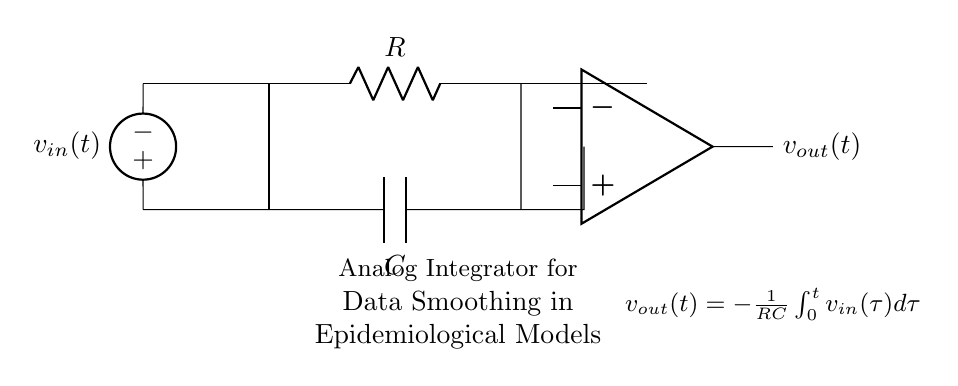What is the primary function of the circuit? The primary function of this circuit is to act as an analog integrator, which smooths data in real-time. This is indicated by the output equation and the arrangement of components.
Answer: Analog integrator What type of components are present in the circuit? The circuit comprises a resistor and a capacitor, which are essential elements for implementing integration in analog circuits. Each component's symbol identifies its role in the circuit.
Answer: Resistor and capacitor What is the output voltage equation for this circuit? The output voltage is given by the equation v out of t equals negative one over RC times the integral of v in from zero to t. This is noted in the circuit diagram.
Answer: v out(t) = -1/RC ∫ v in(τ) dτ How does the resistor value affect the circuit's behavior? The resistor value influences the time constant (RC), which determines how quickly the circuit integrates the input signal. A higher resistance results in a slower response, while a lower resistance leads to faster integration.
Answer: Changes time constant What happens to the output when the input voltage increases? When the input voltage increases, the output voltage will decrease because of the negative relationship defined by the integrator function. This reflects the behavior of an integrator circuit acting on a rising input signal.
Answer: Output decreases What is the physical significance of the capacitor in this circuit? The capacitor serves to store and release energy, enabling the integration of the input voltage over time. This storage is crucial for providing the smoothed output voltage corresponding to the accumulated input.
Answer: Stores energy What is the expected behavior of the circuit during a step input change? The expected behavior during a step input change is that the output will ramp down, representing the integral of the step function over time. This demonstrates how the circuit smooths abrupt changes in the input signal.
Answer: Ramp down 